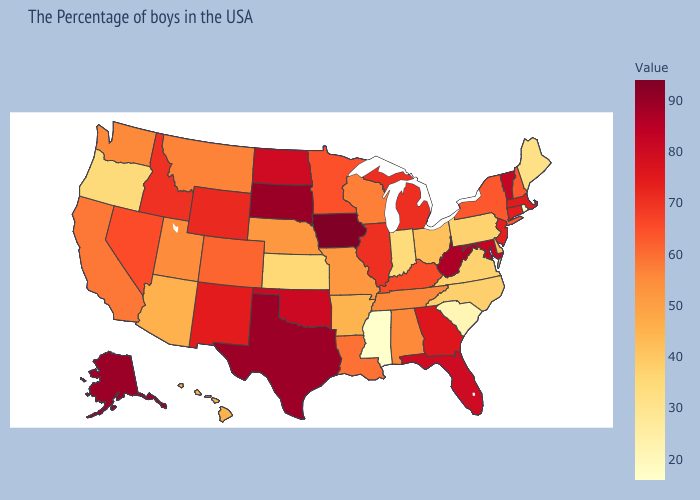Is the legend a continuous bar?
Short answer required. Yes. Does Mississippi have the lowest value in the USA?
Write a very short answer. Yes. Is the legend a continuous bar?
Answer briefly. Yes. 